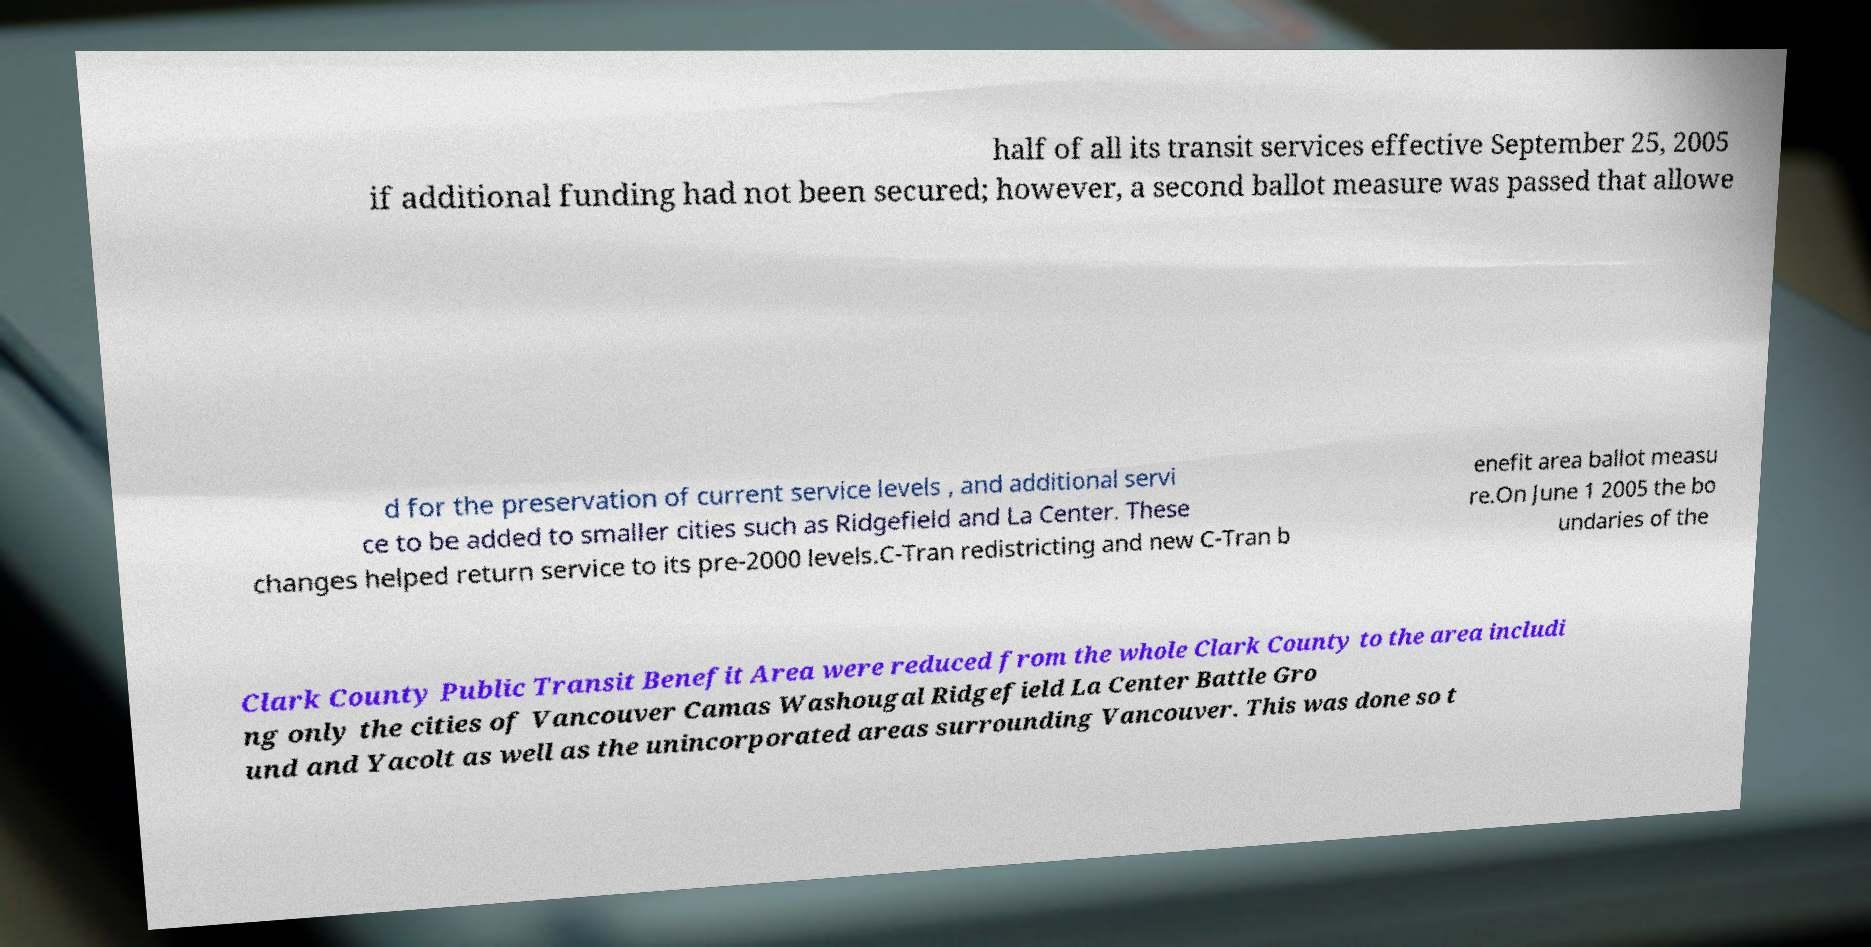What messages or text are displayed in this image? I need them in a readable, typed format. half of all its transit services effective September 25, 2005 if additional funding had not been secured; however, a second ballot measure was passed that allowe d for the preservation of current service levels , and additional servi ce to be added to smaller cities such as Ridgefield and La Center. These changes helped return service to its pre-2000 levels.C-Tran redistricting and new C-Tran b enefit area ballot measu re.On June 1 2005 the bo undaries of the Clark County Public Transit Benefit Area were reduced from the whole Clark County to the area includi ng only the cities of Vancouver Camas Washougal Ridgefield La Center Battle Gro und and Yacolt as well as the unincorporated areas surrounding Vancouver. This was done so t 